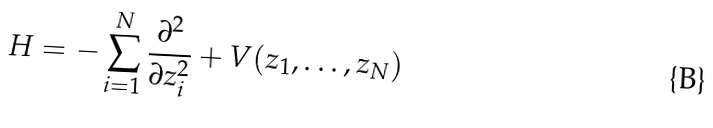Convert formula to latex. <formula><loc_0><loc_0><loc_500><loc_500>H = - \sum _ { i = 1 } ^ { N } \frac { \partial ^ { 2 } } { \partial z _ { i } ^ { 2 } } + V ( z _ { 1 } , \dots , z _ { N } )</formula> 